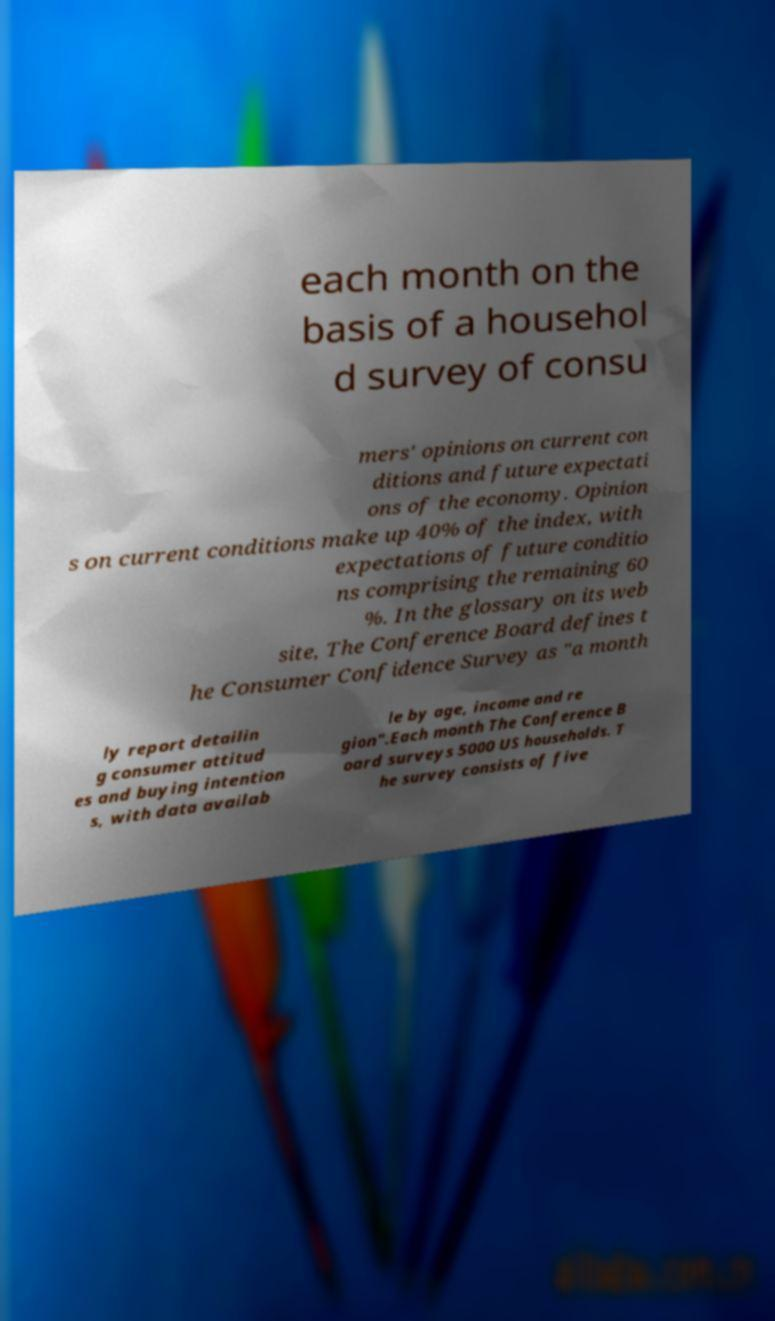Can you accurately transcribe the text from the provided image for me? each month on the basis of a househol d survey of consu mers' opinions on current con ditions and future expectati ons of the economy. Opinion s on current conditions make up 40% of the index, with expectations of future conditio ns comprising the remaining 60 %. In the glossary on its web site, The Conference Board defines t he Consumer Confidence Survey as "a month ly report detailin g consumer attitud es and buying intention s, with data availab le by age, income and re gion".Each month The Conference B oard surveys 5000 US households. T he survey consists of five 